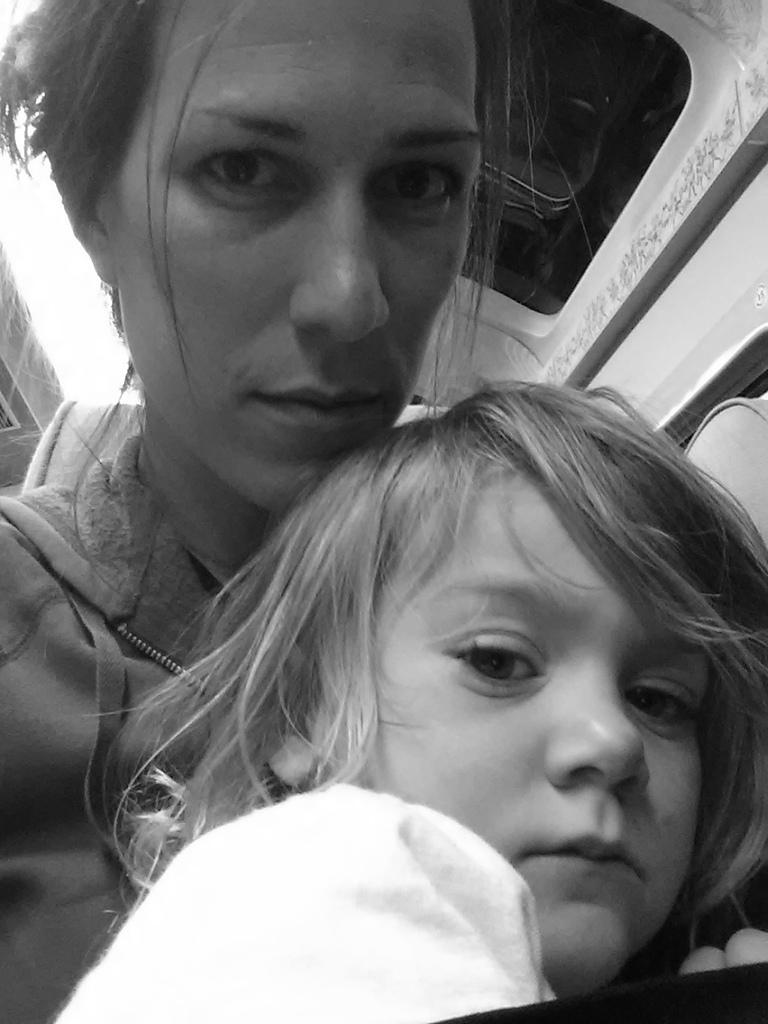Who is present in the image? There is a woman and a girl in the image. What is the woman doing in the image? The woman appears to be seated in a vehicle. What type of pain is the woman experiencing in the image? There is no indication of pain in the image; the woman appears to be seated in a vehicle. 